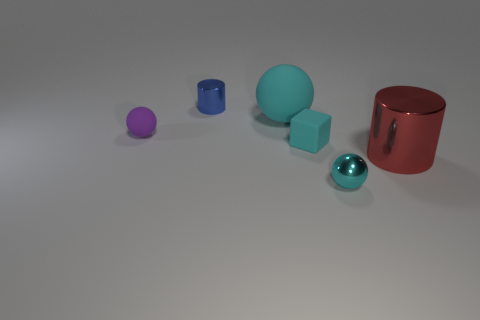How many matte objects are in front of the small ball behind the cyan metal object?
Offer a terse response. 1. There is a cyan object that is in front of the big thing that is right of the ball in front of the tiny purple rubber ball; what shape is it?
Make the answer very short. Sphere. The metallic object that is the same color as the large matte sphere is what size?
Your answer should be very brief. Small. What number of things are either small cyan matte blocks or yellow metal spheres?
Ensure brevity in your answer.  1. What is the color of the sphere that is the same size as the cyan metal thing?
Give a very brief answer. Purple. Is the shape of the big red metal thing the same as the metal object behind the rubber cube?
Offer a terse response. Yes. How many objects are either things that are in front of the purple matte object or things on the left side of the red metallic cylinder?
Ensure brevity in your answer.  6. The big object that is the same color as the shiny sphere is what shape?
Provide a succinct answer. Sphere. What shape is the small metallic thing in front of the small blue metal cylinder?
Provide a short and direct response. Sphere. There is a small cyan thing on the right side of the small cyan block; does it have the same shape as the tiny purple thing?
Your response must be concise. Yes. 